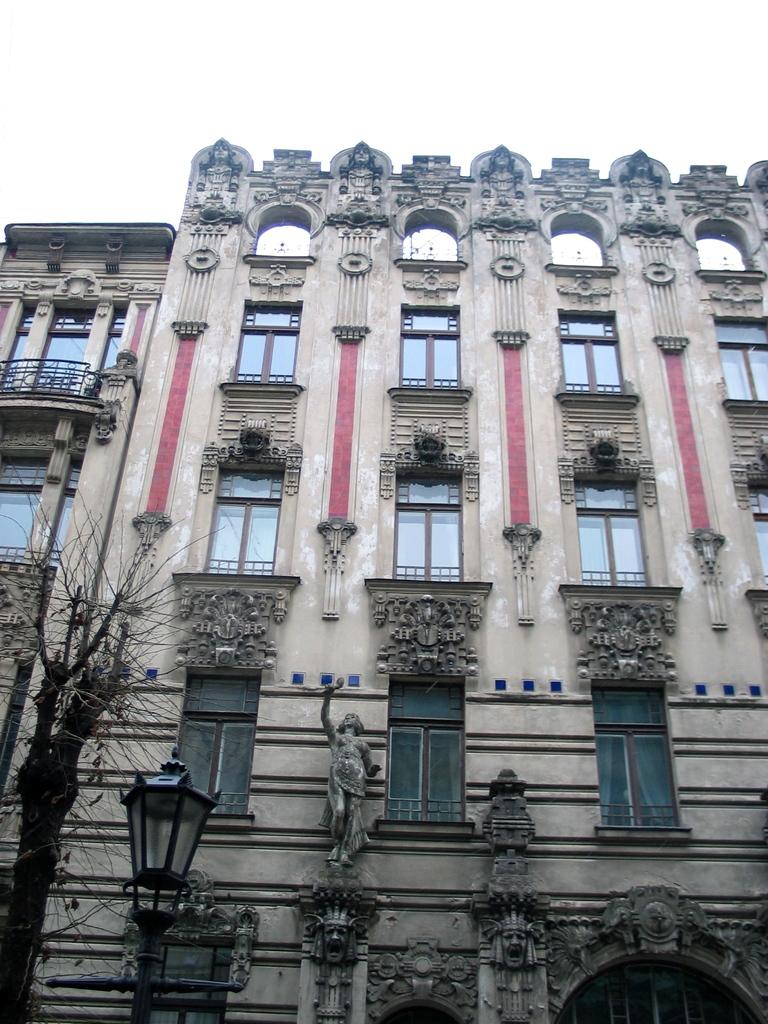What type of light can be seen in the bottom left corner of the image? There is a pole light in the bottom left corner of the image. What is the main structure visible in the image? There is a big building in the image. What type of turkey can be seen in the window of the big building in the image? There is no turkey or window present in the image; it only features a pole light and a big building. What type of beef is being served in the big building in the image? There is no beef or indication of food in the image; it only features a pole light and a big building. 